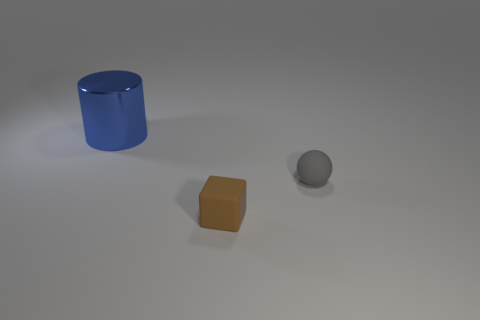Compared to the other objects, where is the sphere located? The sphere is situated to the right of the small brown cube and in front of the blue cylinder, positioned slightly towards the center of the image. Is there any significance to their arrangement? The arrangement may not hold any particular significance beyond compositional aesthetics; the objects are placed with enough distance to be individually identifiable, yet close enough to be seen as part of a collective grouping. 